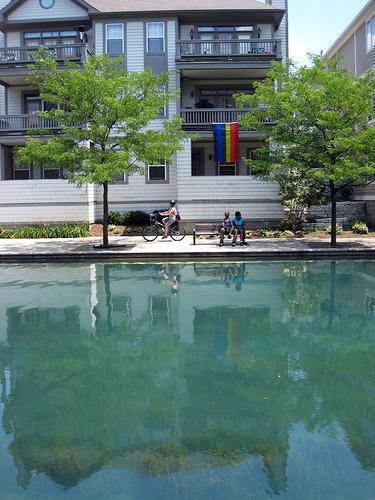How many people are shown?
Give a very brief answer. 3. How many people are sitting?
Give a very brief answer. 2. 